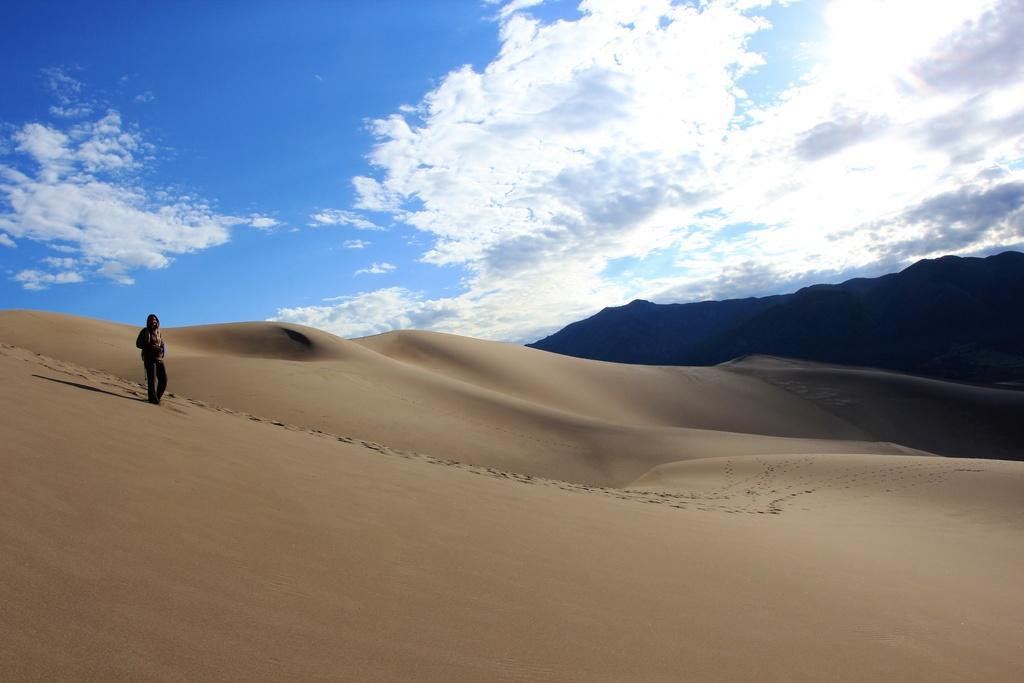Can you describe this image briefly? In this image there is the sky towards the top of the image, there are clouds in the sky, there is a mountain towards the right of the image, there is sand towards the bottom of the image, there is a man standing on the sand. 